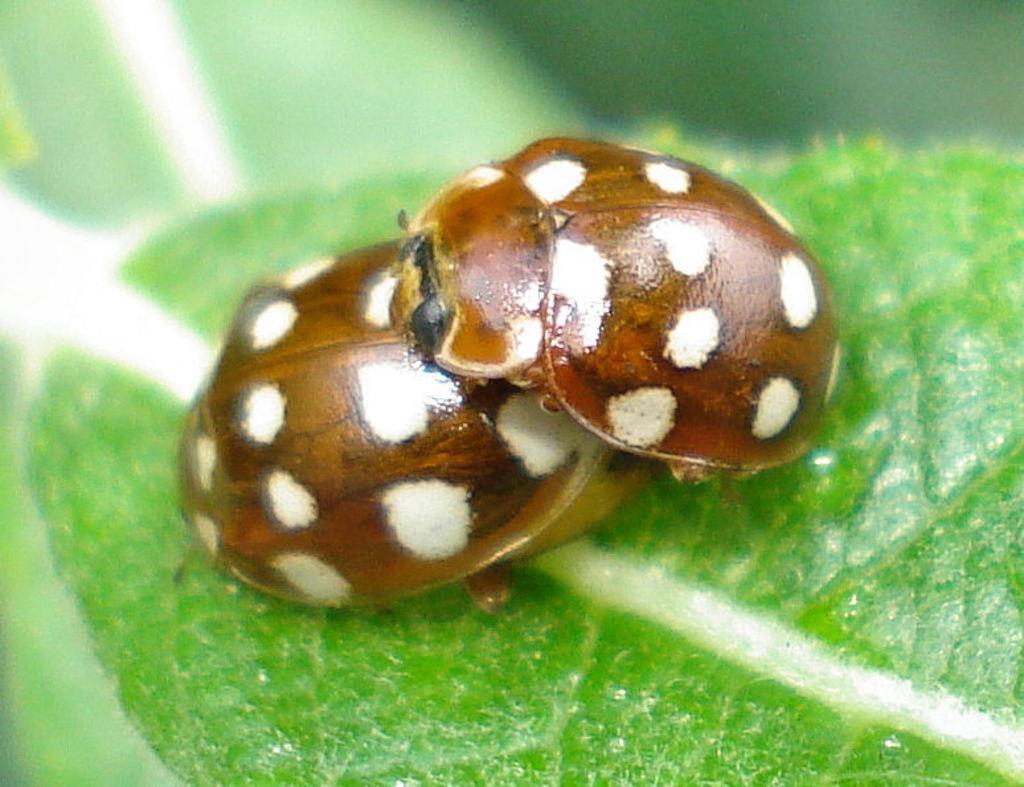Could you give a brief overview of what you see in this image? The picture consists of ladybugs on a leaf. The background is blurred. 